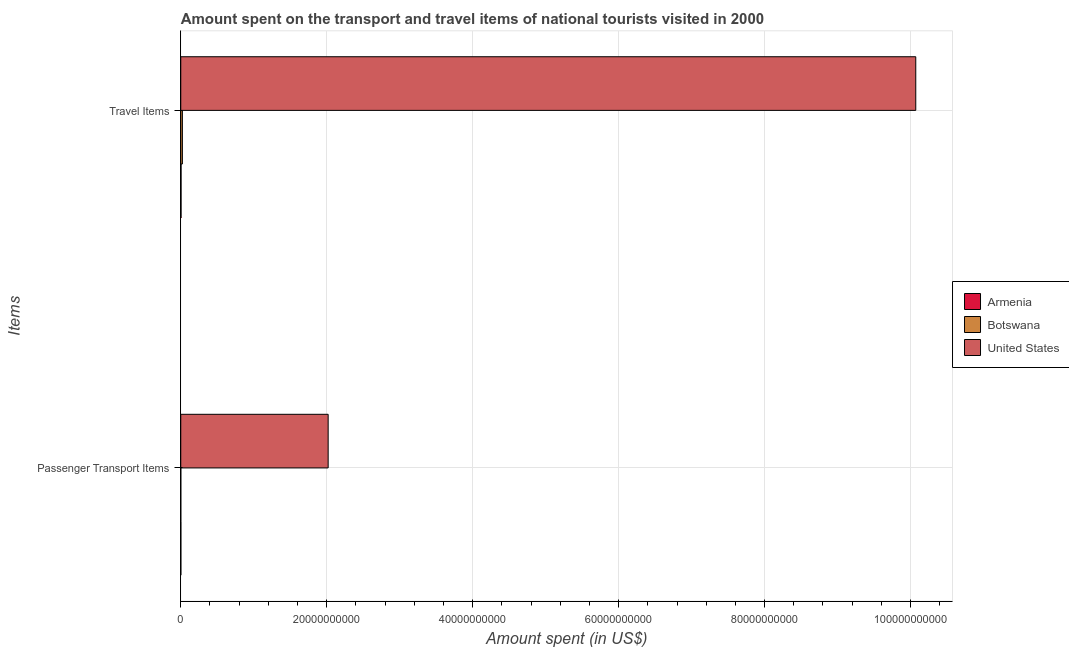How many different coloured bars are there?
Your answer should be very brief. 3. How many groups of bars are there?
Provide a succinct answer. 2. What is the label of the 1st group of bars from the top?
Keep it short and to the point. Travel Items. What is the amount spent in travel items in United States?
Keep it short and to the point. 1.01e+11. Across all countries, what is the maximum amount spent on passenger transport items?
Ensure brevity in your answer.  2.02e+1. Across all countries, what is the minimum amount spent in travel items?
Provide a short and direct response. 3.80e+07. In which country was the amount spent on passenger transport items maximum?
Your response must be concise. United States. In which country was the amount spent in travel items minimum?
Ensure brevity in your answer.  Armenia. What is the total amount spent in travel items in the graph?
Provide a short and direct response. 1.01e+11. What is the difference between the amount spent on passenger transport items in Armenia and that in United States?
Give a very brief answer. -2.02e+1. What is the difference between the amount spent in travel items in United States and the amount spent on passenger transport items in Botswana?
Your answer should be very brief. 1.01e+11. What is the average amount spent in travel items per country?
Provide a succinct answer. 3.37e+1. What is the difference between the amount spent on passenger transport items and amount spent in travel items in Botswana?
Your response must be concise. -2.17e+08. What is the ratio of the amount spent on passenger transport items in Armenia to that in Botswana?
Keep it short and to the point. 2.8. What does the 2nd bar from the bottom in Passenger Transport Items represents?
Your answer should be compact. Botswana. Are all the bars in the graph horizontal?
Your answer should be compact. Yes. How many legend labels are there?
Ensure brevity in your answer.  3. How are the legend labels stacked?
Provide a short and direct response. Vertical. What is the title of the graph?
Offer a terse response. Amount spent on the transport and travel items of national tourists visited in 2000. Does "Turkey" appear as one of the legend labels in the graph?
Provide a succinct answer. No. What is the label or title of the X-axis?
Keep it short and to the point. Amount spent (in US$). What is the label or title of the Y-axis?
Your response must be concise. Items. What is the Amount spent (in US$) in Armenia in Passenger Transport Items?
Offer a very short reply. 1.40e+07. What is the Amount spent (in US$) in Botswana in Passenger Transport Items?
Your answer should be compact. 5.00e+06. What is the Amount spent (in US$) of United States in Passenger Transport Items?
Keep it short and to the point. 2.02e+1. What is the Amount spent (in US$) in Armenia in Travel Items?
Ensure brevity in your answer.  3.80e+07. What is the Amount spent (in US$) in Botswana in Travel Items?
Provide a short and direct response. 2.22e+08. What is the Amount spent (in US$) of United States in Travel Items?
Keep it short and to the point. 1.01e+11. Across all Items, what is the maximum Amount spent (in US$) of Armenia?
Ensure brevity in your answer.  3.80e+07. Across all Items, what is the maximum Amount spent (in US$) in Botswana?
Your answer should be very brief. 2.22e+08. Across all Items, what is the maximum Amount spent (in US$) of United States?
Your response must be concise. 1.01e+11. Across all Items, what is the minimum Amount spent (in US$) of Armenia?
Your response must be concise. 1.40e+07. Across all Items, what is the minimum Amount spent (in US$) of United States?
Ensure brevity in your answer.  2.02e+1. What is the total Amount spent (in US$) of Armenia in the graph?
Offer a terse response. 5.20e+07. What is the total Amount spent (in US$) of Botswana in the graph?
Provide a short and direct response. 2.27e+08. What is the total Amount spent (in US$) of United States in the graph?
Ensure brevity in your answer.  1.21e+11. What is the difference between the Amount spent (in US$) in Armenia in Passenger Transport Items and that in Travel Items?
Your answer should be very brief. -2.40e+07. What is the difference between the Amount spent (in US$) in Botswana in Passenger Transport Items and that in Travel Items?
Your answer should be compact. -2.17e+08. What is the difference between the Amount spent (in US$) in United States in Passenger Transport Items and that in Travel Items?
Provide a succinct answer. -8.05e+1. What is the difference between the Amount spent (in US$) of Armenia in Passenger Transport Items and the Amount spent (in US$) of Botswana in Travel Items?
Make the answer very short. -2.08e+08. What is the difference between the Amount spent (in US$) of Armenia in Passenger Transport Items and the Amount spent (in US$) of United States in Travel Items?
Your response must be concise. -1.01e+11. What is the difference between the Amount spent (in US$) in Botswana in Passenger Transport Items and the Amount spent (in US$) in United States in Travel Items?
Your answer should be very brief. -1.01e+11. What is the average Amount spent (in US$) of Armenia per Items?
Offer a terse response. 2.60e+07. What is the average Amount spent (in US$) in Botswana per Items?
Make the answer very short. 1.14e+08. What is the average Amount spent (in US$) in United States per Items?
Give a very brief answer. 6.05e+1. What is the difference between the Amount spent (in US$) in Armenia and Amount spent (in US$) in Botswana in Passenger Transport Items?
Make the answer very short. 9.00e+06. What is the difference between the Amount spent (in US$) in Armenia and Amount spent (in US$) in United States in Passenger Transport Items?
Your answer should be very brief. -2.02e+1. What is the difference between the Amount spent (in US$) of Botswana and Amount spent (in US$) of United States in Passenger Transport Items?
Ensure brevity in your answer.  -2.02e+1. What is the difference between the Amount spent (in US$) in Armenia and Amount spent (in US$) in Botswana in Travel Items?
Keep it short and to the point. -1.84e+08. What is the difference between the Amount spent (in US$) in Armenia and Amount spent (in US$) in United States in Travel Items?
Give a very brief answer. -1.01e+11. What is the difference between the Amount spent (in US$) of Botswana and Amount spent (in US$) of United States in Travel Items?
Give a very brief answer. -1.00e+11. What is the ratio of the Amount spent (in US$) of Armenia in Passenger Transport Items to that in Travel Items?
Offer a terse response. 0.37. What is the ratio of the Amount spent (in US$) in Botswana in Passenger Transport Items to that in Travel Items?
Offer a very short reply. 0.02. What is the ratio of the Amount spent (in US$) in United States in Passenger Transport Items to that in Travel Items?
Give a very brief answer. 0.2. What is the difference between the highest and the second highest Amount spent (in US$) in Armenia?
Keep it short and to the point. 2.40e+07. What is the difference between the highest and the second highest Amount spent (in US$) of Botswana?
Your answer should be very brief. 2.17e+08. What is the difference between the highest and the second highest Amount spent (in US$) in United States?
Your answer should be very brief. 8.05e+1. What is the difference between the highest and the lowest Amount spent (in US$) of Armenia?
Provide a succinct answer. 2.40e+07. What is the difference between the highest and the lowest Amount spent (in US$) of Botswana?
Your answer should be very brief. 2.17e+08. What is the difference between the highest and the lowest Amount spent (in US$) of United States?
Keep it short and to the point. 8.05e+1. 